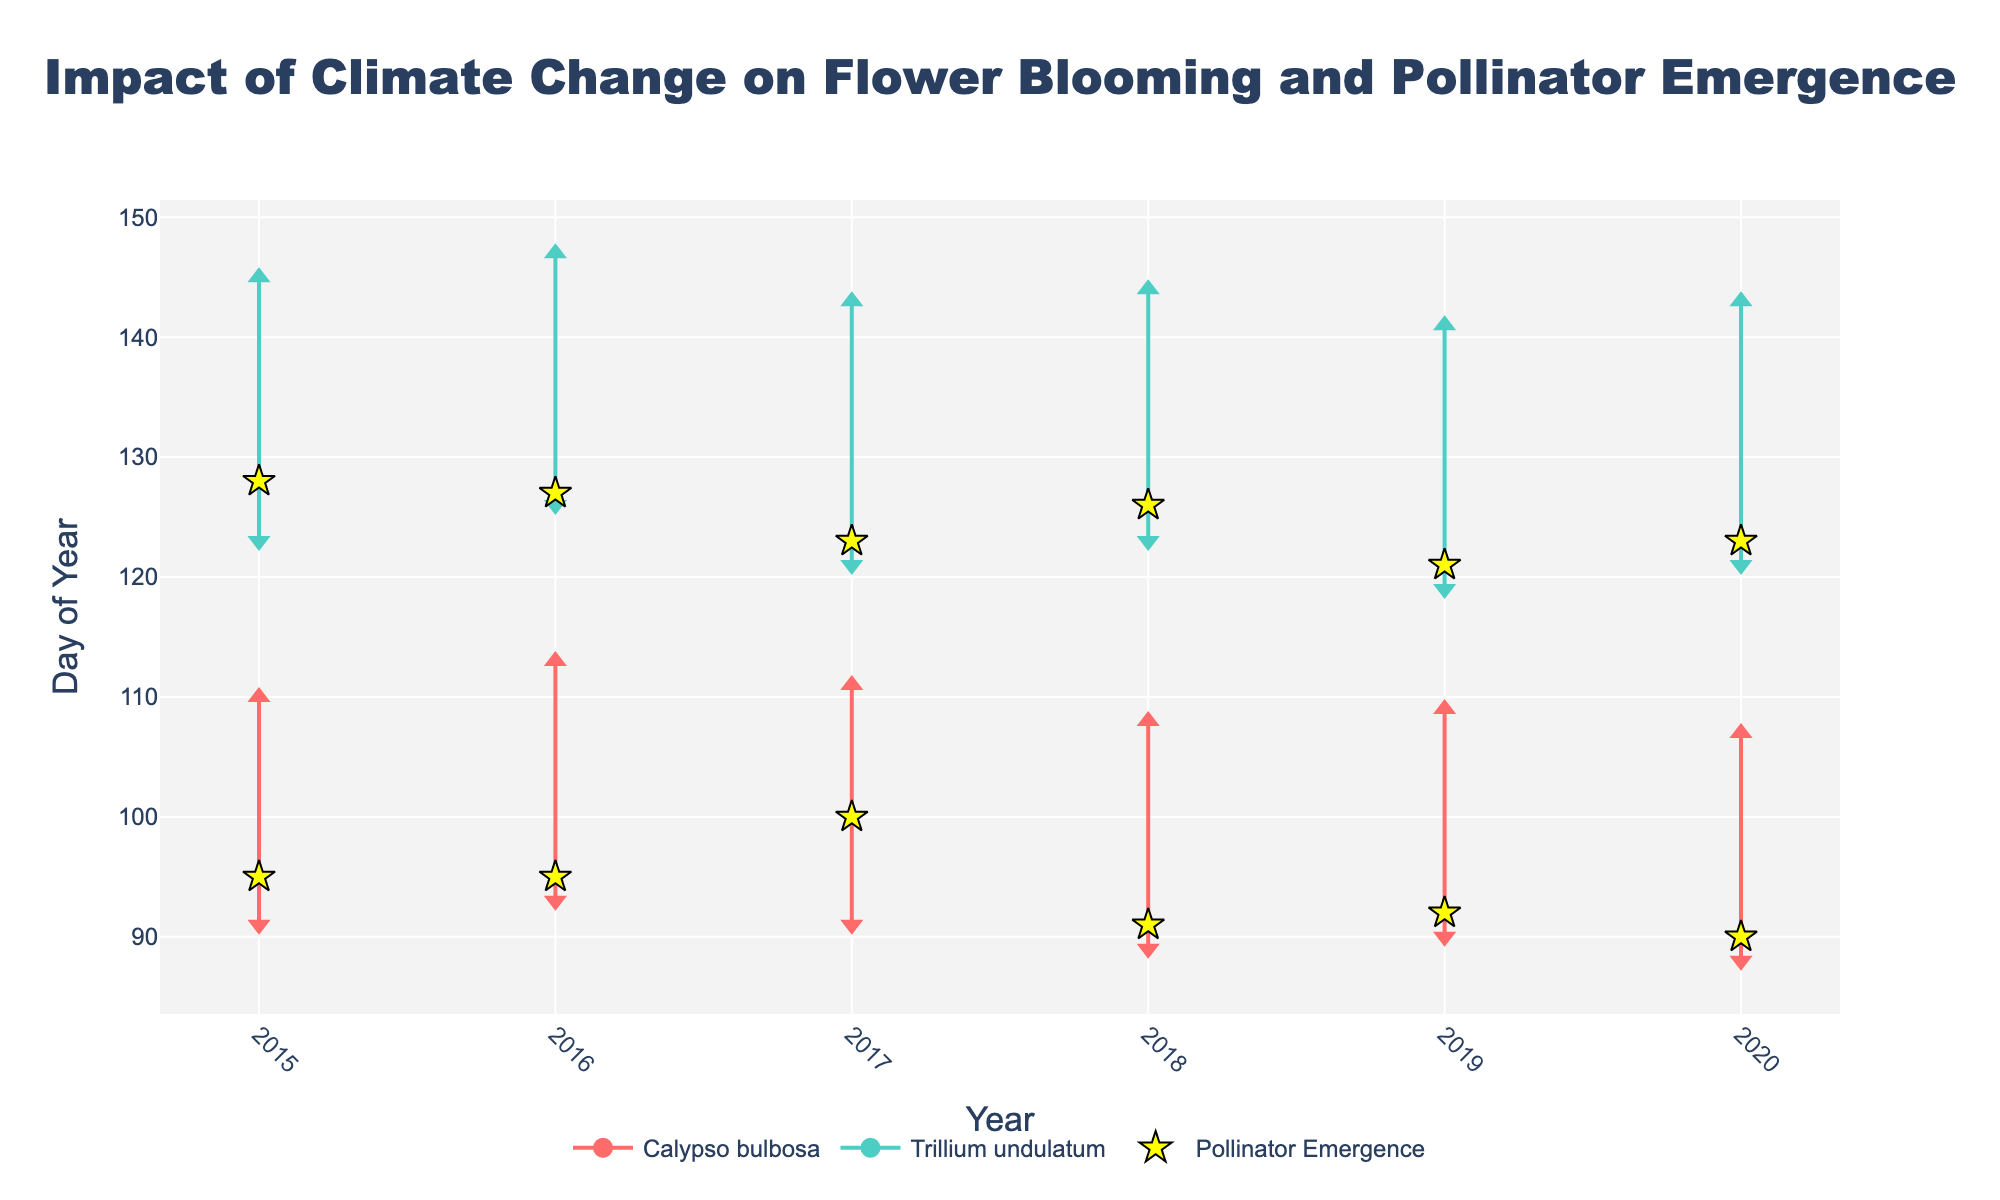What is the title of the figure? The title of the figure is prominently displayed at the top and reads 'Impact of Climate Change on Flower Blooming and Pollinator Emergence'.
Answer: Impact of Climate Change on Flower Blooming and Pollinator Emergence What do the yellow star markers represent? The yellow star markers represent the pollinator emergence dates. This can be deduced from the legend in the figure.
Answer: Pollinator emergence dates What is the significance of the different colors used in the plot? The different colors represent different flower species. This is shown in the legend, where '#FF6B6B' corresponds to 'Calypso bulbosa' and '#4ECDC4' corresponds to 'Trillium undulatum'.
Answer: Different flower species Which flower species show an earlier bloom start date in later years (2018-2020)? Looking at the red lines representing 'Calypso bulbosa', we can see that the bloom start date shifts slightly earlier in the year from 2018 to 2020.
Answer: Calypso bulbosa How do the bloom end dates for 'Trillium undulatum' compare across the years? The bloom end dates for 'Trillium undulatum', represented by the light blue lines, stay relatively consistent from year to year, roughly ending around day 145 of the year.
Answer: Relatively consistent Which year shows the most overlap between 'Calypso bulbosa' bloom period and 'Apis mellifera' emergence? By observing the red lines and yellow star markers for 'Calypso bulbosa' and 'Apis mellifera', the year 2020 shows the most overlap, with both events happening very close to each other around the beginning of April.
Answer: 2020 What is the average bloom end date for 'Calypso bulbosa' from 2015 to 2020? The bloom end dates for 'Calypso bulbosa' are around day 110 each year. Averaging these, (110+112+111+110+109+106)/6 = 109.67 approximately.
Answer: 110 (approx.) How does the pollinator emergence date for 'Bombus terrestris' in 2015 compare to 2020? Comparing the yellow star markers for 'Bombus terrestris' in 2015 and 2020, the emergence date has moved slightly earlier in the year, from around day 128 to day 123.
Answer: Earlier in 2020 What can be inferred about the synchronization between 'Trillium undulatum' blooming and 'Bombus terrestris' emergence over the years? By observing the light blue lines and yellow star markers for 'Trillium undulatum' and 'Bombus terrestris', the synchronization appears consistent with minor variations, indicating a stable relationship despite yearly fluctuations.
Answer: Stable relationship 